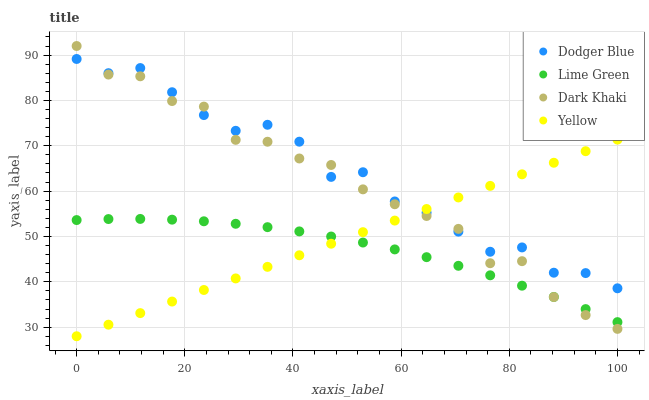Does Lime Green have the minimum area under the curve?
Answer yes or no. Yes. Does Dodger Blue have the maximum area under the curve?
Answer yes or no. Yes. Does Dodger Blue have the minimum area under the curve?
Answer yes or no. No. Does Lime Green have the maximum area under the curve?
Answer yes or no. No. Is Yellow the smoothest?
Answer yes or no. Yes. Is Dodger Blue the roughest?
Answer yes or no. Yes. Is Lime Green the smoothest?
Answer yes or no. No. Is Lime Green the roughest?
Answer yes or no. No. Does Yellow have the lowest value?
Answer yes or no. Yes. Does Lime Green have the lowest value?
Answer yes or no. No. Does Dark Khaki have the highest value?
Answer yes or no. Yes. Does Dodger Blue have the highest value?
Answer yes or no. No. Is Lime Green less than Dodger Blue?
Answer yes or no. Yes. Is Dodger Blue greater than Lime Green?
Answer yes or no. Yes. Does Yellow intersect Dark Khaki?
Answer yes or no. Yes. Is Yellow less than Dark Khaki?
Answer yes or no. No. Is Yellow greater than Dark Khaki?
Answer yes or no. No. Does Lime Green intersect Dodger Blue?
Answer yes or no. No. 